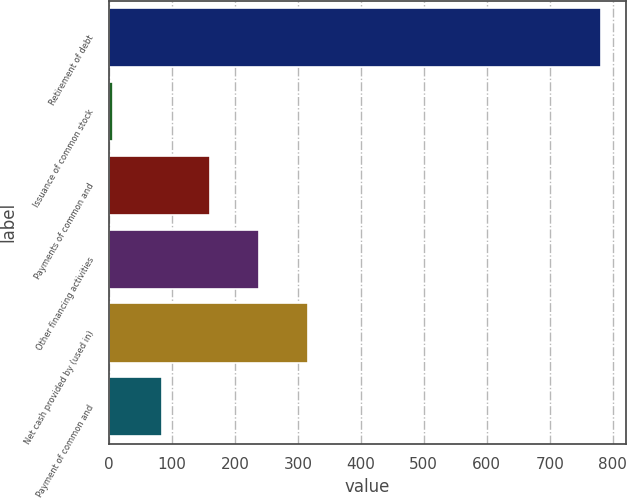<chart> <loc_0><loc_0><loc_500><loc_500><bar_chart><fcel>Retirement of debt<fcel>Issuance of common stock<fcel>Payments of common and<fcel>Other financing activities<fcel>Net cash provided by (used in)<fcel>Payment of common and<nl><fcel>782<fcel>6<fcel>161.2<fcel>238.8<fcel>316.4<fcel>83.6<nl></chart> 